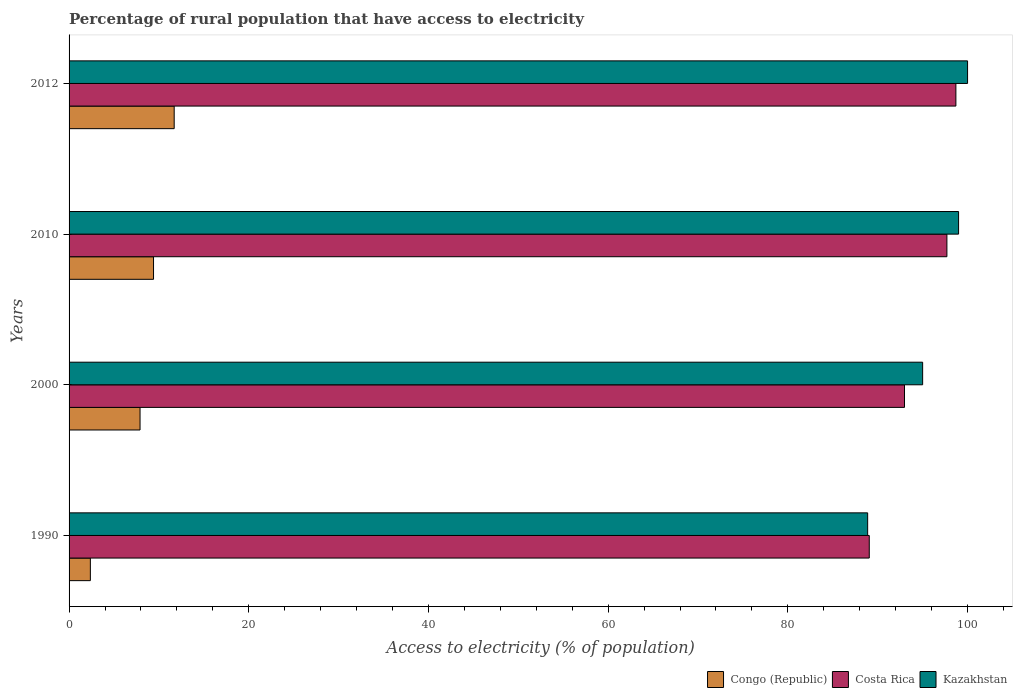How many groups of bars are there?
Offer a very short reply. 4. Are the number of bars per tick equal to the number of legend labels?
Keep it short and to the point. Yes. Are the number of bars on each tick of the Y-axis equal?
Your answer should be very brief. Yes. How many bars are there on the 3rd tick from the top?
Your answer should be very brief. 3. How many bars are there on the 1st tick from the bottom?
Make the answer very short. 3. In how many cases, is the number of bars for a given year not equal to the number of legend labels?
Provide a succinct answer. 0. What is the percentage of rural population that have access to electricity in Kazakhstan in 2012?
Your answer should be very brief. 100. Across all years, what is the maximum percentage of rural population that have access to electricity in Kazakhstan?
Make the answer very short. 100. Across all years, what is the minimum percentage of rural population that have access to electricity in Kazakhstan?
Offer a very short reply. 88.88. In which year was the percentage of rural population that have access to electricity in Kazakhstan minimum?
Offer a very short reply. 1990. What is the total percentage of rural population that have access to electricity in Congo (Republic) in the graph?
Give a very brief answer. 31.37. What is the difference between the percentage of rural population that have access to electricity in Congo (Republic) in 2000 and that in 2012?
Keep it short and to the point. -3.8. What is the difference between the percentage of rural population that have access to electricity in Kazakhstan in 1990 and the percentage of rural population that have access to electricity in Costa Rica in 2012?
Provide a short and direct response. -9.82. What is the average percentage of rural population that have access to electricity in Costa Rica per year?
Your answer should be very brief. 94.61. In the year 2010, what is the difference between the percentage of rural population that have access to electricity in Costa Rica and percentage of rural population that have access to electricity in Kazakhstan?
Provide a short and direct response. -1.3. What is the ratio of the percentage of rural population that have access to electricity in Kazakhstan in 2000 to that in 2010?
Make the answer very short. 0.96. Is the percentage of rural population that have access to electricity in Kazakhstan in 2010 less than that in 2012?
Your answer should be compact. Yes. Is the difference between the percentage of rural population that have access to electricity in Costa Rica in 2000 and 2012 greater than the difference between the percentage of rural population that have access to electricity in Kazakhstan in 2000 and 2012?
Your answer should be compact. No. What is the difference between the highest and the lowest percentage of rural population that have access to electricity in Kazakhstan?
Your answer should be very brief. 11.12. In how many years, is the percentage of rural population that have access to electricity in Congo (Republic) greater than the average percentage of rural population that have access to electricity in Congo (Republic) taken over all years?
Your answer should be compact. 3. What does the 2nd bar from the top in 2010 represents?
Make the answer very short. Costa Rica. What does the 3rd bar from the bottom in 2012 represents?
Your answer should be very brief. Kazakhstan. Is it the case that in every year, the sum of the percentage of rural population that have access to electricity in Kazakhstan and percentage of rural population that have access to electricity in Congo (Republic) is greater than the percentage of rural population that have access to electricity in Costa Rica?
Your answer should be compact. Yes. How many bars are there?
Keep it short and to the point. 12. How many years are there in the graph?
Your answer should be compact. 4. Does the graph contain grids?
Provide a short and direct response. No. How many legend labels are there?
Make the answer very short. 3. How are the legend labels stacked?
Your answer should be compact. Horizontal. What is the title of the graph?
Provide a succinct answer. Percentage of rural population that have access to electricity. Does "World" appear as one of the legend labels in the graph?
Your response must be concise. No. What is the label or title of the X-axis?
Make the answer very short. Access to electricity (% of population). What is the label or title of the Y-axis?
Your response must be concise. Years. What is the Access to electricity (% of population) in Congo (Republic) in 1990?
Provide a succinct answer. 2.37. What is the Access to electricity (% of population) in Costa Rica in 1990?
Provide a short and direct response. 89.06. What is the Access to electricity (% of population) in Kazakhstan in 1990?
Offer a terse response. 88.88. What is the Access to electricity (% of population) of Congo (Republic) in 2000?
Keep it short and to the point. 7.9. What is the Access to electricity (% of population) of Costa Rica in 2000?
Provide a succinct answer. 92.98. What is the Access to electricity (% of population) in Congo (Republic) in 2010?
Provide a succinct answer. 9.4. What is the Access to electricity (% of population) of Costa Rica in 2010?
Offer a terse response. 97.7. What is the Access to electricity (% of population) in Kazakhstan in 2010?
Ensure brevity in your answer.  99. What is the Access to electricity (% of population) in Costa Rica in 2012?
Provide a short and direct response. 98.7. What is the Access to electricity (% of population) of Kazakhstan in 2012?
Your answer should be compact. 100. Across all years, what is the maximum Access to electricity (% of population) of Costa Rica?
Keep it short and to the point. 98.7. Across all years, what is the maximum Access to electricity (% of population) in Kazakhstan?
Your answer should be very brief. 100. Across all years, what is the minimum Access to electricity (% of population) of Congo (Republic)?
Provide a succinct answer. 2.37. Across all years, what is the minimum Access to electricity (% of population) of Costa Rica?
Your response must be concise. 89.06. Across all years, what is the minimum Access to electricity (% of population) of Kazakhstan?
Keep it short and to the point. 88.88. What is the total Access to electricity (% of population) of Congo (Republic) in the graph?
Ensure brevity in your answer.  31.37. What is the total Access to electricity (% of population) of Costa Rica in the graph?
Offer a very short reply. 378.44. What is the total Access to electricity (% of population) of Kazakhstan in the graph?
Provide a succinct answer. 382.88. What is the difference between the Access to electricity (% of population) of Congo (Republic) in 1990 and that in 2000?
Your response must be concise. -5.53. What is the difference between the Access to electricity (% of population) in Costa Rica in 1990 and that in 2000?
Provide a succinct answer. -3.92. What is the difference between the Access to electricity (% of population) in Kazakhstan in 1990 and that in 2000?
Provide a short and direct response. -6.12. What is the difference between the Access to electricity (% of population) in Congo (Republic) in 1990 and that in 2010?
Your response must be concise. -7.03. What is the difference between the Access to electricity (% of population) of Costa Rica in 1990 and that in 2010?
Your answer should be compact. -8.64. What is the difference between the Access to electricity (% of population) in Kazakhstan in 1990 and that in 2010?
Ensure brevity in your answer.  -10.12. What is the difference between the Access to electricity (% of population) in Congo (Republic) in 1990 and that in 2012?
Provide a succinct answer. -9.33. What is the difference between the Access to electricity (% of population) in Costa Rica in 1990 and that in 2012?
Your answer should be very brief. -9.64. What is the difference between the Access to electricity (% of population) in Kazakhstan in 1990 and that in 2012?
Give a very brief answer. -11.12. What is the difference between the Access to electricity (% of population) in Costa Rica in 2000 and that in 2010?
Your answer should be compact. -4.72. What is the difference between the Access to electricity (% of population) in Congo (Republic) in 2000 and that in 2012?
Ensure brevity in your answer.  -3.8. What is the difference between the Access to electricity (% of population) in Costa Rica in 2000 and that in 2012?
Ensure brevity in your answer.  -5.72. What is the difference between the Access to electricity (% of population) in Costa Rica in 2010 and that in 2012?
Your answer should be compact. -1. What is the difference between the Access to electricity (% of population) of Kazakhstan in 2010 and that in 2012?
Provide a succinct answer. -1. What is the difference between the Access to electricity (% of population) in Congo (Republic) in 1990 and the Access to electricity (% of population) in Costa Rica in 2000?
Offer a very short reply. -90.61. What is the difference between the Access to electricity (% of population) of Congo (Republic) in 1990 and the Access to electricity (% of population) of Kazakhstan in 2000?
Offer a very short reply. -92.63. What is the difference between the Access to electricity (% of population) in Costa Rica in 1990 and the Access to electricity (% of population) in Kazakhstan in 2000?
Your answer should be compact. -5.94. What is the difference between the Access to electricity (% of population) of Congo (Republic) in 1990 and the Access to electricity (% of population) of Costa Rica in 2010?
Ensure brevity in your answer.  -95.33. What is the difference between the Access to electricity (% of population) in Congo (Republic) in 1990 and the Access to electricity (% of population) in Kazakhstan in 2010?
Ensure brevity in your answer.  -96.63. What is the difference between the Access to electricity (% of population) of Costa Rica in 1990 and the Access to electricity (% of population) of Kazakhstan in 2010?
Ensure brevity in your answer.  -9.94. What is the difference between the Access to electricity (% of population) of Congo (Republic) in 1990 and the Access to electricity (% of population) of Costa Rica in 2012?
Give a very brief answer. -96.33. What is the difference between the Access to electricity (% of population) in Congo (Republic) in 1990 and the Access to electricity (% of population) in Kazakhstan in 2012?
Offer a terse response. -97.63. What is the difference between the Access to electricity (% of population) in Costa Rica in 1990 and the Access to electricity (% of population) in Kazakhstan in 2012?
Offer a terse response. -10.94. What is the difference between the Access to electricity (% of population) of Congo (Republic) in 2000 and the Access to electricity (% of population) of Costa Rica in 2010?
Offer a terse response. -89.8. What is the difference between the Access to electricity (% of population) of Congo (Republic) in 2000 and the Access to electricity (% of population) of Kazakhstan in 2010?
Your answer should be very brief. -91.1. What is the difference between the Access to electricity (% of population) of Costa Rica in 2000 and the Access to electricity (% of population) of Kazakhstan in 2010?
Provide a succinct answer. -6.02. What is the difference between the Access to electricity (% of population) of Congo (Republic) in 2000 and the Access to electricity (% of population) of Costa Rica in 2012?
Provide a short and direct response. -90.8. What is the difference between the Access to electricity (% of population) in Congo (Republic) in 2000 and the Access to electricity (% of population) in Kazakhstan in 2012?
Your response must be concise. -92.1. What is the difference between the Access to electricity (% of population) in Costa Rica in 2000 and the Access to electricity (% of population) in Kazakhstan in 2012?
Keep it short and to the point. -7.02. What is the difference between the Access to electricity (% of population) of Congo (Republic) in 2010 and the Access to electricity (% of population) of Costa Rica in 2012?
Ensure brevity in your answer.  -89.3. What is the difference between the Access to electricity (% of population) in Congo (Republic) in 2010 and the Access to electricity (% of population) in Kazakhstan in 2012?
Offer a very short reply. -90.6. What is the average Access to electricity (% of population) in Congo (Republic) per year?
Keep it short and to the point. 7.84. What is the average Access to electricity (% of population) of Costa Rica per year?
Keep it short and to the point. 94.61. What is the average Access to electricity (% of population) in Kazakhstan per year?
Ensure brevity in your answer.  95.72. In the year 1990, what is the difference between the Access to electricity (% of population) in Congo (Republic) and Access to electricity (% of population) in Costa Rica?
Offer a terse response. -86.69. In the year 1990, what is the difference between the Access to electricity (% of population) in Congo (Republic) and Access to electricity (% of population) in Kazakhstan?
Give a very brief answer. -86.51. In the year 1990, what is the difference between the Access to electricity (% of population) in Costa Rica and Access to electricity (% of population) in Kazakhstan?
Keep it short and to the point. 0.18. In the year 2000, what is the difference between the Access to electricity (% of population) of Congo (Republic) and Access to electricity (% of population) of Costa Rica?
Your answer should be very brief. -85.08. In the year 2000, what is the difference between the Access to electricity (% of population) in Congo (Republic) and Access to electricity (% of population) in Kazakhstan?
Provide a short and direct response. -87.1. In the year 2000, what is the difference between the Access to electricity (% of population) of Costa Rica and Access to electricity (% of population) of Kazakhstan?
Offer a terse response. -2.02. In the year 2010, what is the difference between the Access to electricity (% of population) in Congo (Republic) and Access to electricity (% of population) in Costa Rica?
Your response must be concise. -88.3. In the year 2010, what is the difference between the Access to electricity (% of population) in Congo (Republic) and Access to electricity (% of population) in Kazakhstan?
Provide a succinct answer. -89.6. In the year 2012, what is the difference between the Access to electricity (% of population) in Congo (Republic) and Access to electricity (% of population) in Costa Rica?
Keep it short and to the point. -87. In the year 2012, what is the difference between the Access to electricity (% of population) in Congo (Republic) and Access to electricity (% of population) in Kazakhstan?
Offer a terse response. -88.3. In the year 2012, what is the difference between the Access to electricity (% of population) of Costa Rica and Access to electricity (% of population) of Kazakhstan?
Your answer should be compact. -1.3. What is the ratio of the Access to electricity (% of population) in Congo (Republic) in 1990 to that in 2000?
Your answer should be compact. 0.3. What is the ratio of the Access to electricity (% of population) of Costa Rica in 1990 to that in 2000?
Make the answer very short. 0.96. What is the ratio of the Access to electricity (% of population) of Kazakhstan in 1990 to that in 2000?
Make the answer very short. 0.94. What is the ratio of the Access to electricity (% of population) in Congo (Republic) in 1990 to that in 2010?
Your response must be concise. 0.25. What is the ratio of the Access to electricity (% of population) in Costa Rica in 1990 to that in 2010?
Your answer should be compact. 0.91. What is the ratio of the Access to electricity (% of population) in Kazakhstan in 1990 to that in 2010?
Your answer should be compact. 0.9. What is the ratio of the Access to electricity (% of population) of Congo (Republic) in 1990 to that in 2012?
Offer a very short reply. 0.2. What is the ratio of the Access to electricity (% of population) of Costa Rica in 1990 to that in 2012?
Give a very brief answer. 0.9. What is the ratio of the Access to electricity (% of population) in Kazakhstan in 1990 to that in 2012?
Give a very brief answer. 0.89. What is the ratio of the Access to electricity (% of population) in Congo (Republic) in 2000 to that in 2010?
Make the answer very short. 0.84. What is the ratio of the Access to electricity (% of population) in Costa Rica in 2000 to that in 2010?
Provide a short and direct response. 0.95. What is the ratio of the Access to electricity (% of population) of Kazakhstan in 2000 to that in 2010?
Provide a succinct answer. 0.96. What is the ratio of the Access to electricity (% of population) of Congo (Republic) in 2000 to that in 2012?
Make the answer very short. 0.68. What is the ratio of the Access to electricity (% of population) of Costa Rica in 2000 to that in 2012?
Provide a succinct answer. 0.94. What is the ratio of the Access to electricity (% of population) of Congo (Republic) in 2010 to that in 2012?
Offer a very short reply. 0.8. What is the ratio of the Access to electricity (% of population) of Costa Rica in 2010 to that in 2012?
Keep it short and to the point. 0.99. What is the ratio of the Access to electricity (% of population) of Kazakhstan in 2010 to that in 2012?
Keep it short and to the point. 0.99. What is the difference between the highest and the second highest Access to electricity (% of population) of Congo (Republic)?
Your answer should be very brief. 2.3. What is the difference between the highest and the second highest Access to electricity (% of population) of Costa Rica?
Provide a short and direct response. 1. What is the difference between the highest and the second highest Access to electricity (% of population) in Kazakhstan?
Ensure brevity in your answer.  1. What is the difference between the highest and the lowest Access to electricity (% of population) in Congo (Republic)?
Ensure brevity in your answer.  9.33. What is the difference between the highest and the lowest Access to electricity (% of population) of Costa Rica?
Offer a terse response. 9.64. What is the difference between the highest and the lowest Access to electricity (% of population) of Kazakhstan?
Provide a succinct answer. 11.12. 